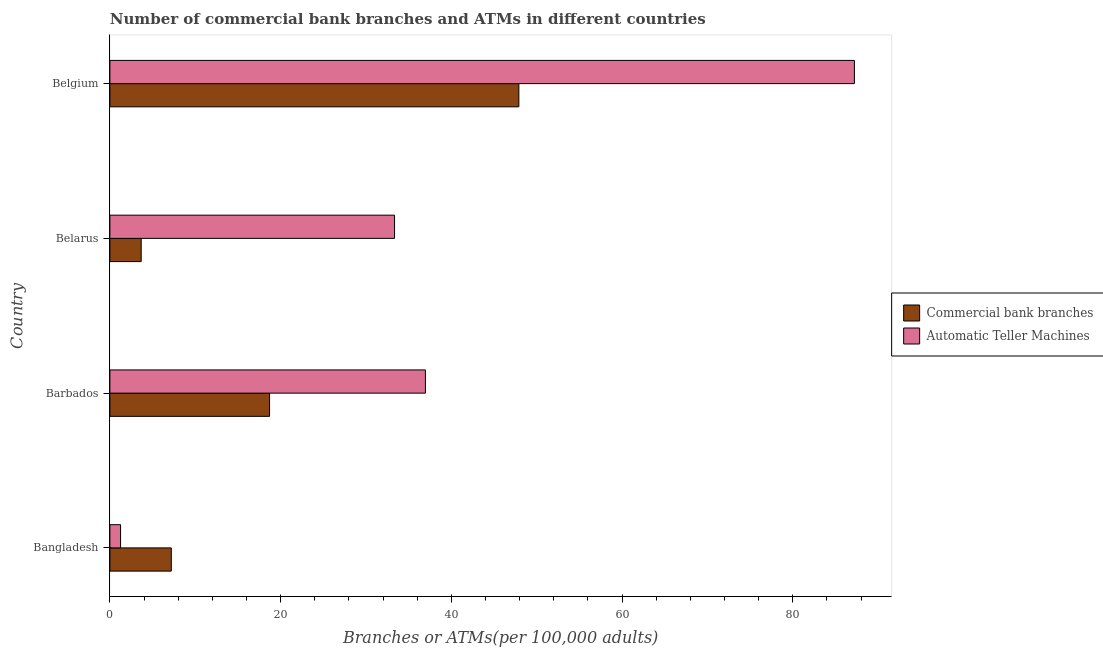How many groups of bars are there?
Provide a short and direct response. 4. Are the number of bars per tick equal to the number of legend labels?
Make the answer very short. Yes. How many bars are there on the 4th tick from the bottom?
Offer a very short reply. 2. What is the number of atms in Belarus?
Provide a short and direct response. 33.35. Across all countries, what is the maximum number of atms?
Your response must be concise. 87.23. Across all countries, what is the minimum number of commercal bank branches?
Offer a terse response. 3.67. In which country was the number of commercal bank branches minimum?
Provide a short and direct response. Belarus. What is the total number of atms in the graph?
Provide a succinct answer. 158.8. What is the difference between the number of commercal bank branches in Barbados and that in Belgium?
Provide a short and direct response. -29.21. What is the difference between the number of commercal bank branches in Bangladesh and the number of atms in Belgium?
Keep it short and to the point. -80.03. What is the average number of commercal bank branches per country?
Your answer should be compact. 19.37. What is the difference between the number of atms and number of commercal bank branches in Barbados?
Offer a terse response. 18.26. What is the ratio of the number of atms in Bangladesh to that in Barbados?
Give a very brief answer. 0.03. Is the number of commercal bank branches in Bangladesh less than that in Belarus?
Give a very brief answer. No. What is the difference between the highest and the second highest number of commercal bank branches?
Your answer should be compact. 29.21. What is the difference between the highest and the lowest number of atms?
Your answer should be compact. 85.98. Is the sum of the number of atms in Bangladesh and Belarus greater than the maximum number of commercal bank branches across all countries?
Give a very brief answer. No. What does the 2nd bar from the top in Belarus represents?
Your response must be concise. Commercial bank branches. What does the 1st bar from the bottom in Belgium represents?
Provide a short and direct response. Commercial bank branches. Are all the bars in the graph horizontal?
Make the answer very short. Yes. Does the graph contain grids?
Make the answer very short. No. Where does the legend appear in the graph?
Keep it short and to the point. Center right. How many legend labels are there?
Make the answer very short. 2. How are the legend labels stacked?
Keep it short and to the point. Vertical. What is the title of the graph?
Keep it short and to the point. Number of commercial bank branches and ATMs in different countries. What is the label or title of the X-axis?
Your answer should be compact. Branches or ATMs(per 100,0 adults). What is the label or title of the Y-axis?
Your response must be concise. Country. What is the Branches or ATMs(per 100,000 adults) in Commercial bank branches in Bangladesh?
Provide a short and direct response. 7.19. What is the Branches or ATMs(per 100,000 adults) in Automatic Teller Machines in Bangladesh?
Give a very brief answer. 1.25. What is the Branches or ATMs(per 100,000 adults) of Commercial bank branches in Barbados?
Your answer should be compact. 18.71. What is the Branches or ATMs(per 100,000 adults) of Automatic Teller Machines in Barbados?
Ensure brevity in your answer.  36.97. What is the Branches or ATMs(per 100,000 adults) of Commercial bank branches in Belarus?
Provide a succinct answer. 3.67. What is the Branches or ATMs(per 100,000 adults) in Automatic Teller Machines in Belarus?
Your answer should be very brief. 33.35. What is the Branches or ATMs(per 100,000 adults) of Commercial bank branches in Belgium?
Offer a terse response. 47.92. What is the Branches or ATMs(per 100,000 adults) in Automatic Teller Machines in Belgium?
Your response must be concise. 87.23. Across all countries, what is the maximum Branches or ATMs(per 100,000 adults) in Commercial bank branches?
Make the answer very short. 47.92. Across all countries, what is the maximum Branches or ATMs(per 100,000 adults) of Automatic Teller Machines?
Keep it short and to the point. 87.23. Across all countries, what is the minimum Branches or ATMs(per 100,000 adults) in Commercial bank branches?
Provide a short and direct response. 3.67. Across all countries, what is the minimum Branches or ATMs(per 100,000 adults) in Automatic Teller Machines?
Your answer should be very brief. 1.25. What is the total Branches or ATMs(per 100,000 adults) of Commercial bank branches in the graph?
Your response must be concise. 77.48. What is the total Branches or ATMs(per 100,000 adults) of Automatic Teller Machines in the graph?
Give a very brief answer. 158.8. What is the difference between the Branches or ATMs(per 100,000 adults) in Commercial bank branches in Bangladesh and that in Barbados?
Make the answer very short. -11.51. What is the difference between the Branches or ATMs(per 100,000 adults) of Automatic Teller Machines in Bangladesh and that in Barbados?
Offer a terse response. -35.72. What is the difference between the Branches or ATMs(per 100,000 adults) in Commercial bank branches in Bangladesh and that in Belarus?
Give a very brief answer. 3.53. What is the difference between the Branches or ATMs(per 100,000 adults) in Automatic Teller Machines in Bangladesh and that in Belarus?
Offer a terse response. -32.1. What is the difference between the Branches or ATMs(per 100,000 adults) of Commercial bank branches in Bangladesh and that in Belgium?
Provide a short and direct response. -40.72. What is the difference between the Branches or ATMs(per 100,000 adults) of Automatic Teller Machines in Bangladesh and that in Belgium?
Your response must be concise. -85.98. What is the difference between the Branches or ATMs(per 100,000 adults) in Commercial bank branches in Barbados and that in Belarus?
Your answer should be compact. 15.04. What is the difference between the Branches or ATMs(per 100,000 adults) in Automatic Teller Machines in Barbados and that in Belarus?
Your answer should be very brief. 3.62. What is the difference between the Branches or ATMs(per 100,000 adults) in Commercial bank branches in Barbados and that in Belgium?
Keep it short and to the point. -29.21. What is the difference between the Branches or ATMs(per 100,000 adults) of Automatic Teller Machines in Barbados and that in Belgium?
Provide a succinct answer. -50.26. What is the difference between the Branches or ATMs(per 100,000 adults) in Commercial bank branches in Belarus and that in Belgium?
Offer a very short reply. -44.25. What is the difference between the Branches or ATMs(per 100,000 adults) of Automatic Teller Machines in Belarus and that in Belgium?
Keep it short and to the point. -53.88. What is the difference between the Branches or ATMs(per 100,000 adults) in Commercial bank branches in Bangladesh and the Branches or ATMs(per 100,000 adults) in Automatic Teller Machines in Barbados?
Offer a terse response. -29.77. What is the difference between the Branches or ATMs(per 100,000 adults) in Commercial bank branches in Bangladesh and the Branches or ATMs(per 100,000 adults) in Automatic Teller Machines in Belarus?
Make the answer very short. -26.16. What is the difference between the Branches or ATMs(per 100,000 adults) of Commercial bank branches in Bangladesh and the Branches or ATMs(per 100,000 adults) of Automatic Teller Machines in Belgium?
Your response must be concise. -80.03. What is the difference between the Branches or ATMs(per 100,000 adults) of Commercial bank branches in Barbados and the Branches or ATMs(per 100,000 adults) of Automatic Teller Machines in Belarus?
Your answer should be compact. -14.64. What is the difference between the Branches or ATMs(per 100,000 adults) of Commercial bank branches in Barbados and the Branches or ATMs(per 100,000 adults) of Automatic Teller Machines in Belgium?
Your answer should be compact. -68.52. What is the difference between the Branches or ATMs(per 100,000 adults) of Commercial bank branches in Belarus and the Branches or ATMs(per 100,000 adults) of Automatic Teller Machines in Belgium?
Keep it short and to the point. -83.56. What is the average Branches or ATMs(per 100,000 adults) of Commercial bank branches per country?
Offer a very short reply. 19.37. What is the average Branches or ATMs(per 100,000 adults) of Automatic Teller Machines per country?
Offer a very short reply. 39.7. What is the difference between the Branches or ATMs(per 100,000 adults) of Commercial bank branches and Branches or ATMs(per 100,000 adults) of Automatic Teller Machines in Bangladesh?
Offer a terse response. 5.94. What is the difference between the Branches or ATMs(per 100,000 adults) of Commercial bank branches and Branches or ATMs(per 100,000 adults) of Automatic Teller Machines in Barbados?
Ensure brevity in your answer.  -18.26. What is the difference between the Branches or ATMs(per 100,000 adults) of Commercial bank branches and Branches or ATMs(per 100,000 adults) of Automatic Teller Machines in Belarus?
Your response must be concise. -29.68. What is the difference between the Branches or ATMs(per 100,000 adults) in Commercial bank branches and Branches or ATMs(per 100,000 adults) in Automatic Teller Machines in Belgium?
Provide a short and direct response. -39.31. What is the ratio of the Branches or ATMs(per 100,000 adults) of Commercial bank branches in Bangladesh to that in Barbados?
Your answer should be very brief. 0.38. What is the ratio of the Branches or ATMs(per 100,000 adults) in Automatic Teller Machines in Bangladesh to that in Barbados?
Offer a terse response. 0.03. What is the ratio of the Branches or ATMs(per 100,000 adults) of Commercial bank branches in Bangladesh to that in Belarus?
Make the answer very short. 1.96. What is the ratio of the Branches or ATMs(per 100,000 adults) of Automatic Teller Machines in Bangladesh to that in Belarus?
Ensure brevity in your answer.  0.04. What is the ratio of the Branches or ATMs(per 100,000 adults) of Commercial bank branches in Bangladesh to that in Belgium?
Provide a succinct answer. 0.15. What is the ratio of the Branches or ATMs(per 100,000 adults) in Automatic Teller Machines in Bangladesh to that in Belgium?
Make the answer very short. 0.01. What is the ratio of the Branches or ATMs(per 100,000 adults) in Commercial bank branches in Barbados to that in Belarus?
Provide a short and direct response. 5.1. What is the ratio of the Branches or ATMs(per 100,000 adults) of Automatic Teller Machines in Barbados to that in Belarus?
Ensure brevity in your answer.  1.11. What is the ratio of the Branches or ATMs(per 100,000 adults) of Commercial bank branches in Barbados to that in Belgium?
Provide a succinct answer. 0.39. What is the ratio of the Branches or ATMs(per 100,000 adults) of Automatic Teller Machines in Barbados to that in Belgium?
Provide a short and direct response. 0.42. What is the ratio of the Branches or ATMs(per 100,000 adults) in Commercial bank branches in Belarus to that in Belgium?
Keep it short and to the point. 0.08. What is the ratio of the Branches or ATMs(per 100,000 adults) of Automatic Teller Machines in Belarus to that in Belgium?
Give a very brief answer. 0.38. What is the difference between the highest and the second highest Branches or ATMs(per 100,000 adults) in Commercial bank branches?
Your answer should be very brief. 29.21. What is the difference between the highest and the second highest Branches or ATMs(per 100,000 adults) in Automatic Teller Machines?
Your answer should be very brief. 50.26. What is the difference between the highest and the lowest Branches or ATMs(per 100,000 adults) in Commercial bank branches?
Your response must be concise. 44.25. What is the difference between the highest and the lowest Branches or ATMs(per 100,000 adults) of Automatic Teller Machines?
Give a very brief answer. 85.98. 